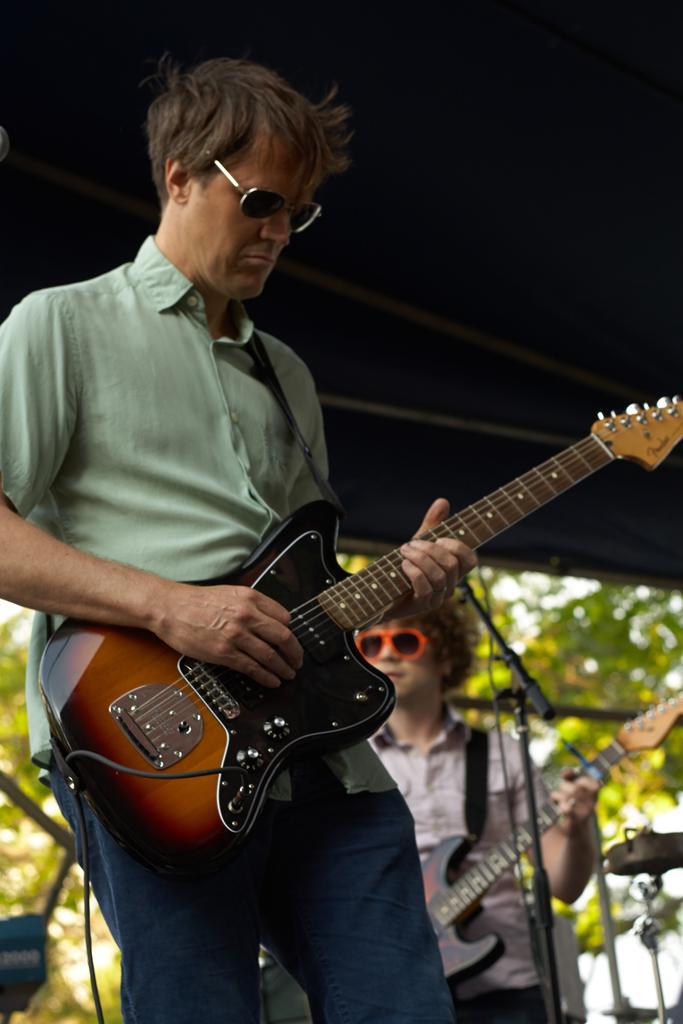Describe this image in one or two sentences. In this image there are two persons. At the foreground of the image there is a person wearing green color shirt playing guitar and at the background of the image there is also a person playing guitar in front of him there is a microphone. 